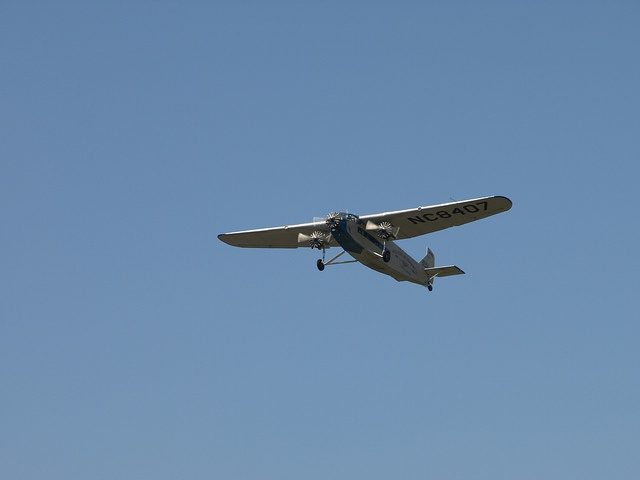Describe the objects in this image and their specific colors. I can see a airplane in gray and black tones in this image. 